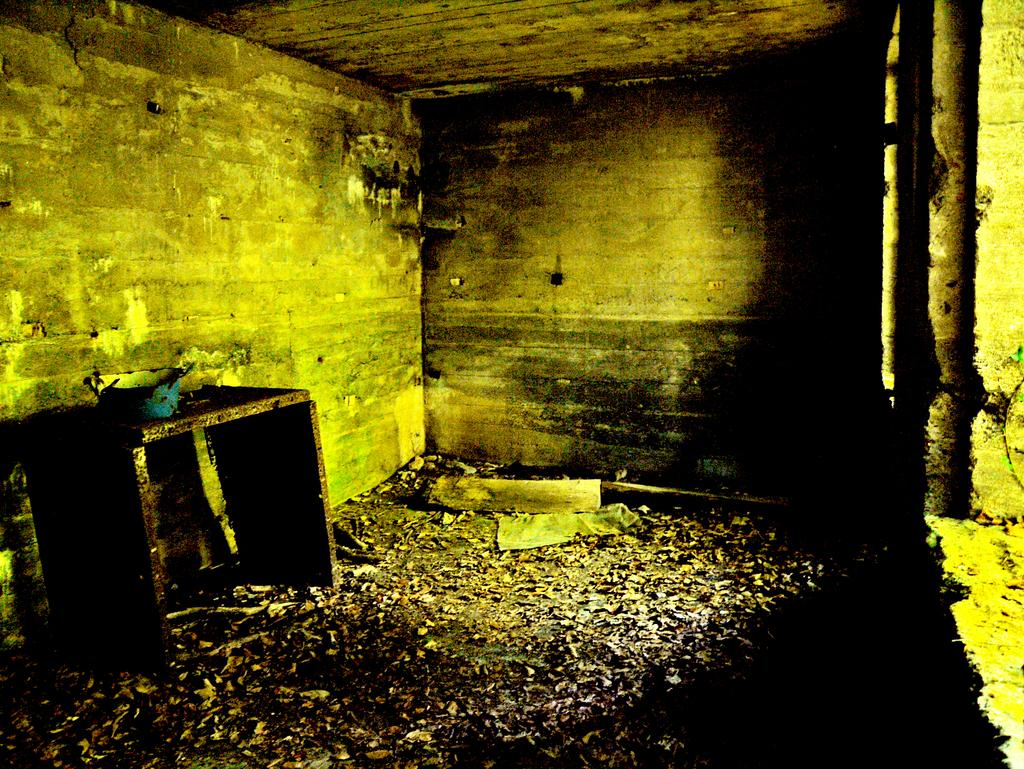What is the color of the object on the wooden surface? The object on the wooden surface is blue. What can be seen on the floor in the image? There are many objects on the floor. What is visible in the background of the image? There is a wall visible in the background. What type of muscle is being flexed by the object on the wooden surface? There is no muscle present in the image, as the main subject is an object on a wooden surface. 